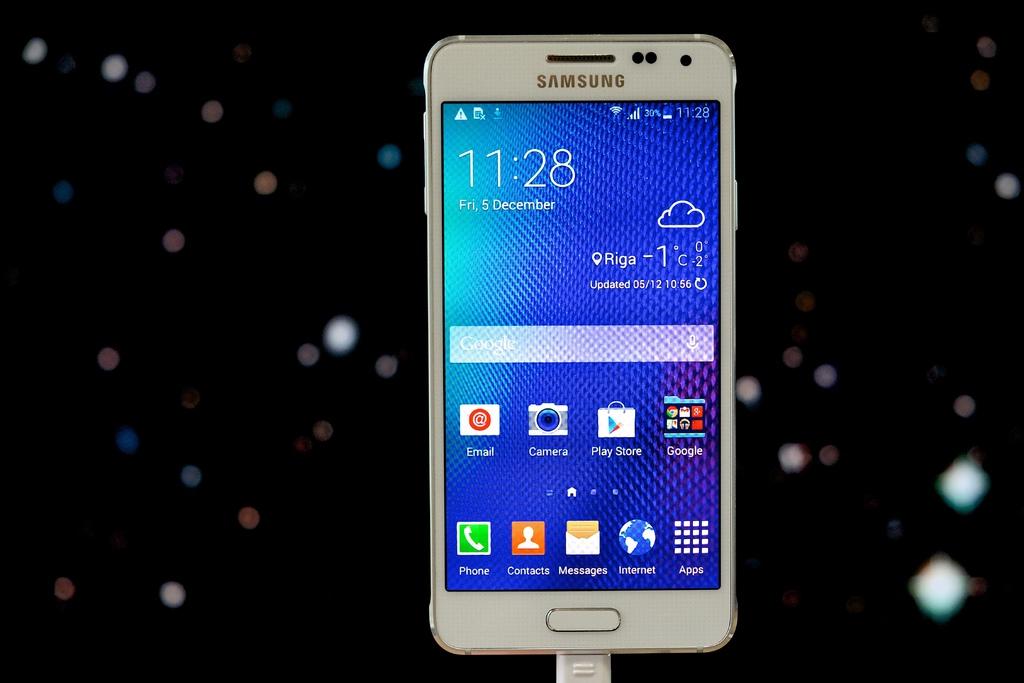What time is it?
Offer a very short reply. 11:28. What is the phone's brand?
Your answer should be very brief. Samsung. 